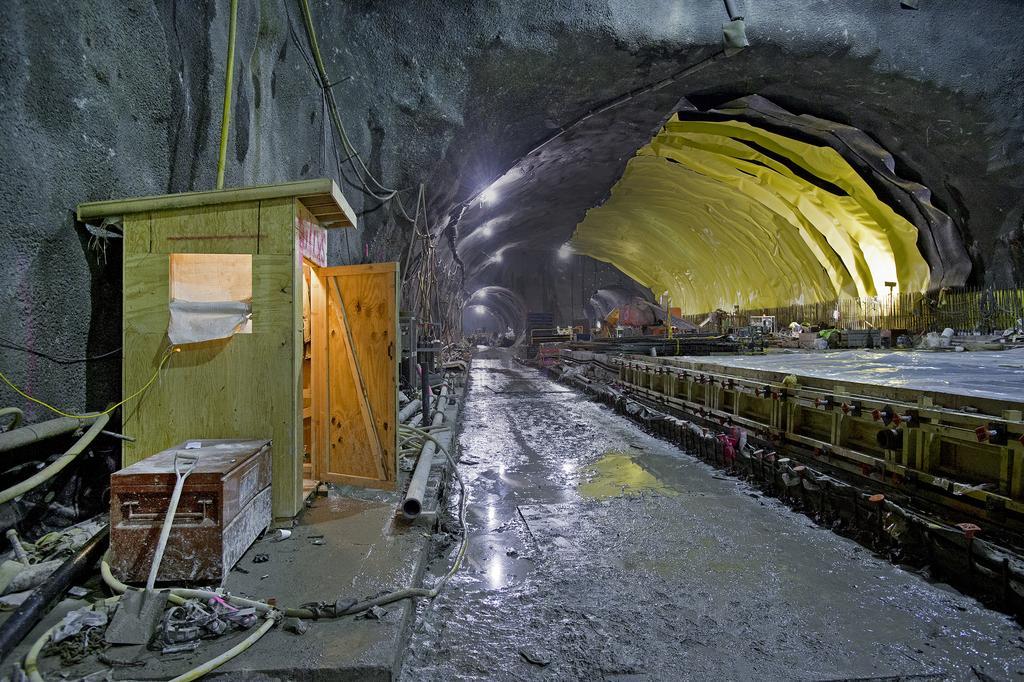Can you describe this image briefly? In this picture we can see a tunnel, in the tunnel we can find a shovel, few pipes, box, cables and lights, and also we can see few people. 